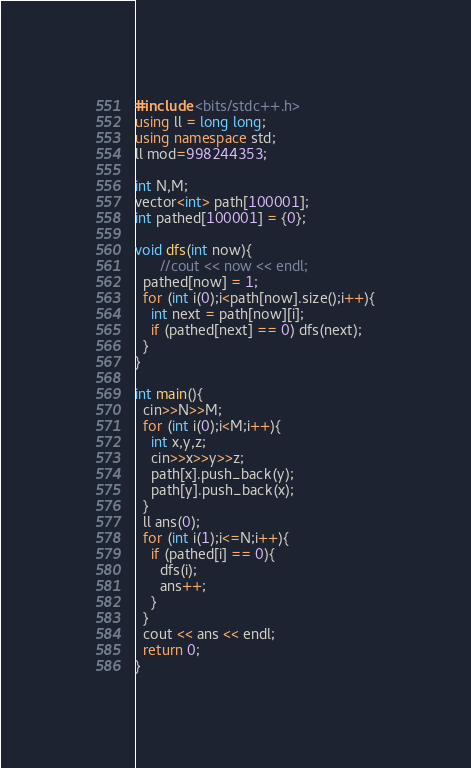<code> <loc_0><loc_0><loc_500><loc_500><_C++_>#include <bits/stdc++.h>
using ll = long long;
using namespace std;
ll mod=998244353;

int N,M;
vector<int> path[100001];
int pathed[100001] = {0};

void dfs(int now){
      //cout << now << endl;
  pathed[now] = 1;
  for (int i(0);i<path[now].size();i++){
    int next = path[now][i]; 
    if (pathed[next] == 0) dfs(next);
  }
}

int main(){
  cin>>N>>M;
  for (int i(0);i<M;i++){
    int x,y,z;
    cin>>x>>y>>z;
    path[x].push_back(y);
    path[y].push_back(x);
  }
  ll ans(0);
  for (int i(1);i<=N;i++){
    if (pathed[i] == 0){
      dfs(i);
      ans++;
    }
  }
  cout << ans << endl;
  return 0;
}
</code> 